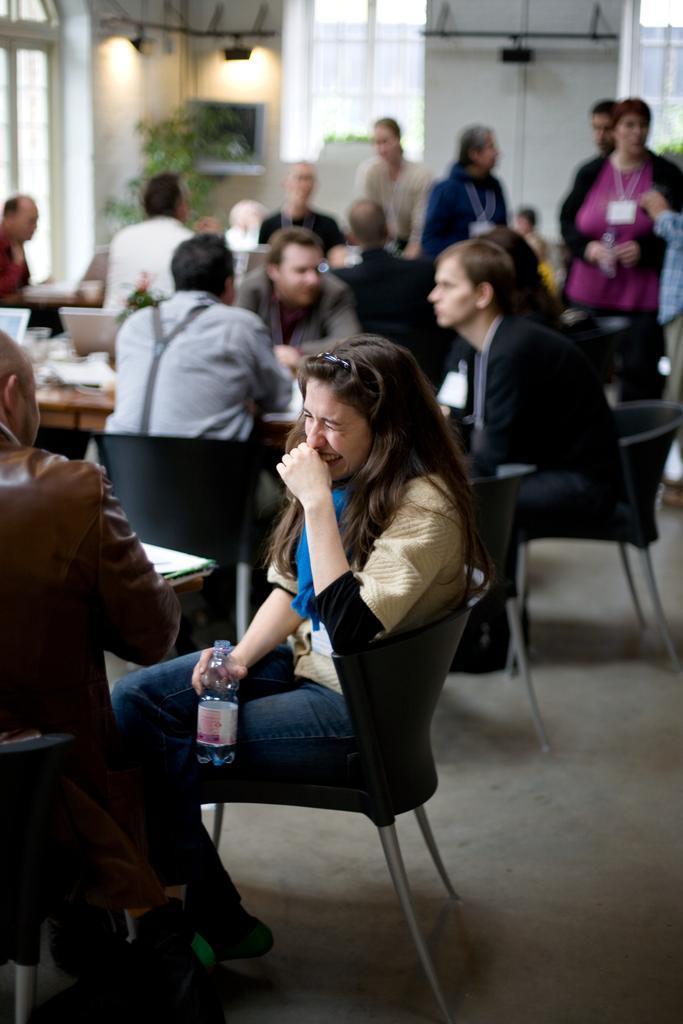Could you give a brief overview of what you see in this image? This picture is clicked inside a restaurant. There are people sitting on chairs and tables. Behind them there are few people standing. The woman at the center is holding a water bottle in her hand and smiling. In the background there is wall, windows lights and plants. 